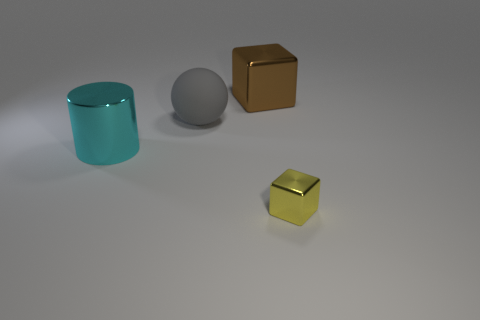What size is the other metallic thing that is the same shape as the brown object?
Your response must be concise. Small. How many tiny cubes have the same material as the large cyan thing?
Offer a terse response. 1. What is the material of the large brown cube?
Your answer should be very brief. Metal. The rubber object that is to the right of the large shiny thing that is in front of the big shiny block is what shape?
Provide a short and direct response. Sphere. There is a metal object that is on the left side of the brown cube; what shape is it?
Provide a short and direct response. Cylinder. What number of blocks have the same color as the large cylinder?
Provide a short and direct response. 0. The small metal object has what color?
Offer a very short reply. Yellow. There is a large metal thing in front of the big rubber ball; what number of big cubes are behind it?
Your answer should be very brief. 1. There is a metal cylinder; is its size the same as the metal cube in front of the cyan metal cylinder?
Your answer should be compact. No. Is the size of the yellow shiny thing the same as the gray rubber object?
Make the answer very short. No. 